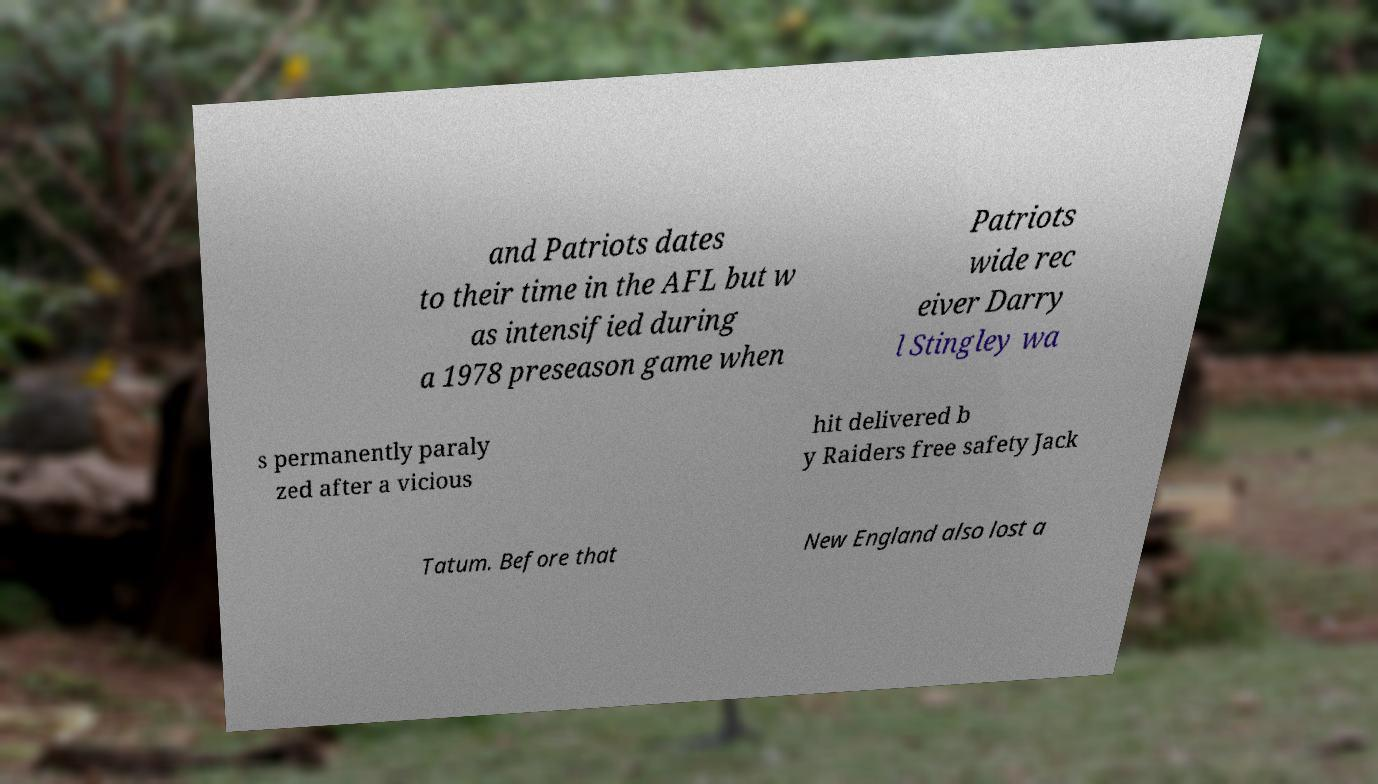Please identify and transcribe the text found in this image. and Patriots dates to their time in the AFL but w as intensified during a 1978 preseason game when Patriots wide rec eiver Darry l Stingley wa s permanently paraly zed after a vicious hit delivered b y Raiders free safety Jack Tatum. Before that New England also lost a 